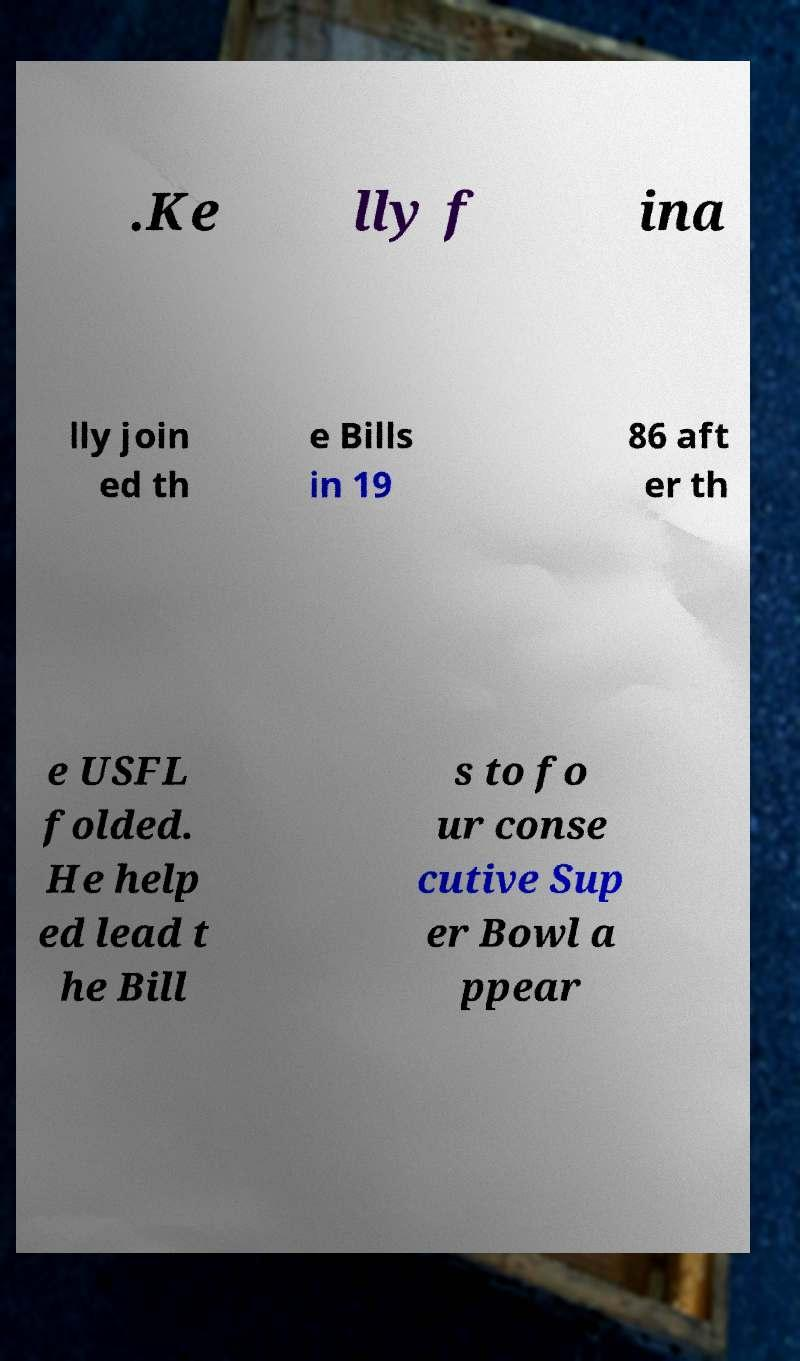For documentation purposes, I need the text within this image transcribed. Could you provide that? .Ke lly f ina lly join ed th e Bills in 19 86 aft er th e USFL folded. He help ed lead t he Bill s to fo ur conse cutive Sup er Bowl a ppear 